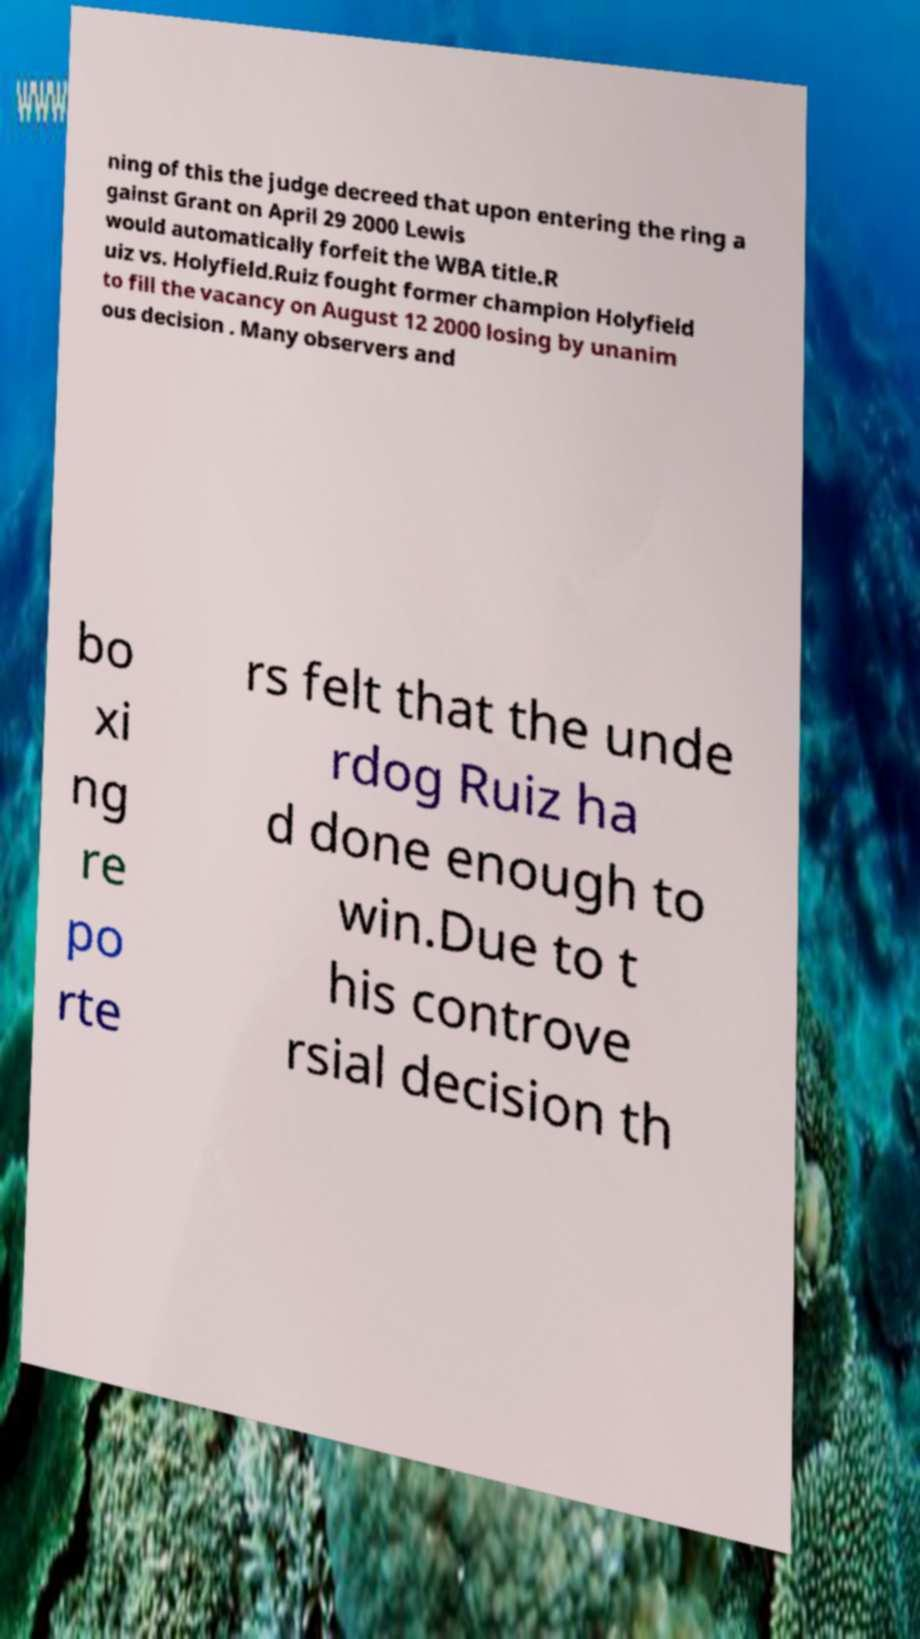Could you assist in decoding the text presented in this image and type it out clearly? ning of this the judge decreed that upon entering the ring a gainst Grant on April 29 2000 Lewis would automatically forfeit the WBA title.R uiz vs. Holyfield.Ruiz fought former champion Holyfield to fill the vacancy on August 12 2000 losing by unanim ous decision . Many observers and bo xi ng re po rte rs felt that the unde rdog Ruiz ha d done enough to win.Due to t his controve rsial decision th 